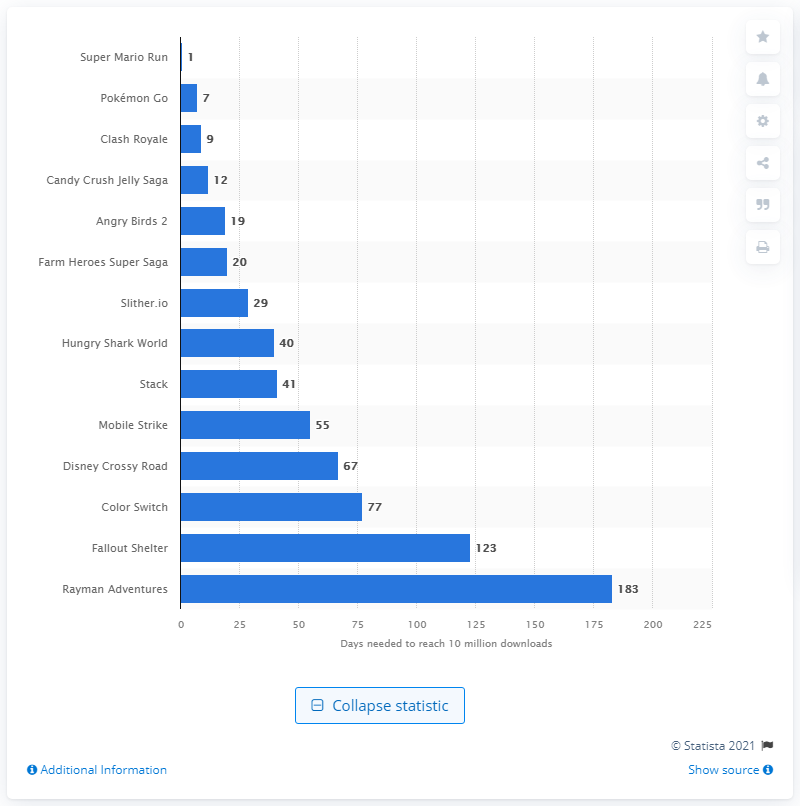Indicate a few pertinent items in this graphic. As of December 2016, Super Mario Run was the fastest mobile game to reach 10 million downloads worldwide, achieving this milestone in just a few days after its release. 